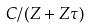<formula> <loc_0><loc_0><loc_500><loc_500>C / ( Z + Z \tau )</formula> 